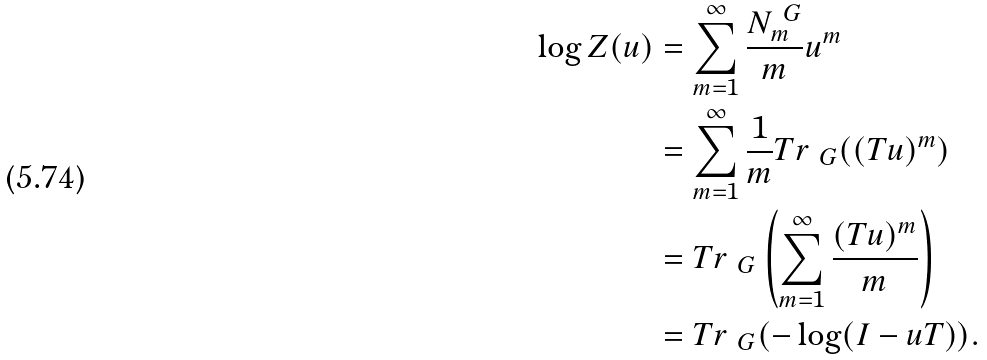Convert formula to latex. <formula><loc_0><loc_0><loc_500><loc_500>\log Z ( u ) & = \sum _ { m = 1 } ^ { \infty } \frac { N ^ { \ G } _ { m } } { m } u ^ { m } \\ & = \sum _ { m = 1 } ^ { \infty } \frac { 1 } { m } T r _ { \ G } ( ( T u ) ^ { m } ) \\ & = T r _ { \ G } \left ( \sum _ { m = 1 } ^ { \infty } \frac { ( T u ) ^ { m } } { m } \right ) \\ & = T r _ { \ G } ( - \log ( I - u T ) ) .</formula> 